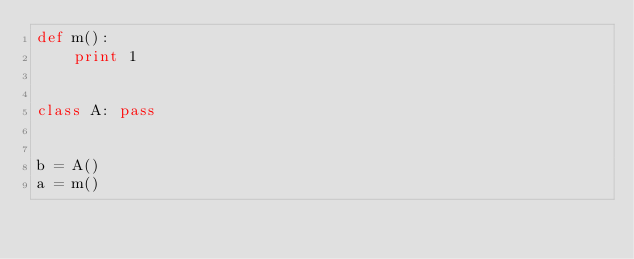<code> <loc_0><loc_0><loc_500><loc_500><_Python_>def m():
    print 1


class A: pass


b = A()
a = m()
</code> 